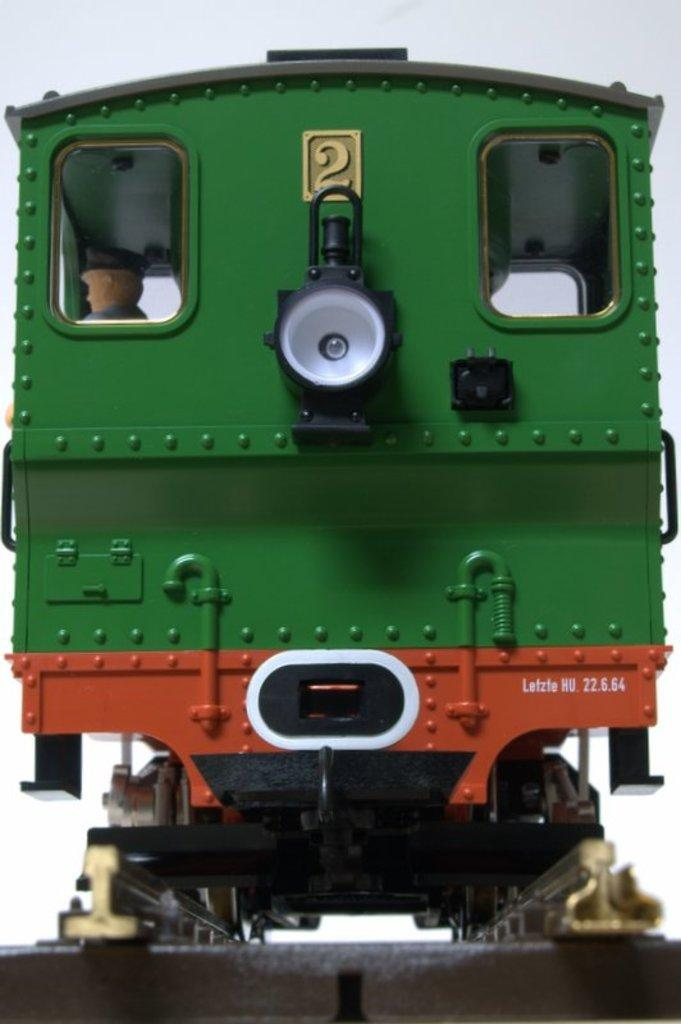What type of image is being described? The image is animated. What is the main subject in the center of the image? There is a train in the center of the image. What colors are used to depict the train? The train is green and red in color. Is there any text or number visible on the train? Yes, there is a number written on the train. What type of dress is the train wearing in the image? The train is not a person and does not wear a dress; it is a mode of transportation. 